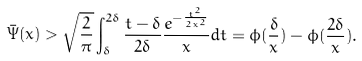<formula> <loc_0><loc_0><loc_500><loc_500>\bar { \Psi } ( x ) > \sqrt { \frac { 2 } { \pi } } \int _ { \delta } ^ { 2 \delta } \frac { t - \delta } { 2 \delta } \frac { e ^ { - \frac { t ^ { 2 } } { 2 x ^ { 2 } } } } { x } d t = \phi ( \frac { \delta } { x } ) - \phi ( \frac { 2 \delta } { x } ) .</formula> 